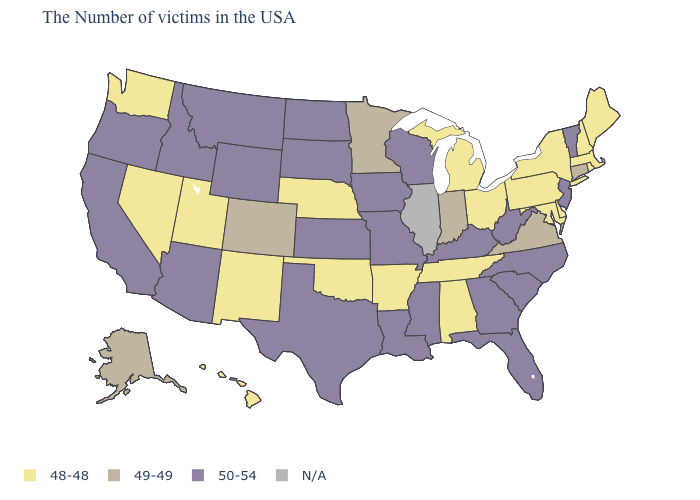Name the states that have a value in the range N/A?
Quick response, please. Illinois. What is the value of Florida?
Write a very short answer. 50-54. What is the value of Massachusetts?
Answer briefly. 48-48. Which states hav the highest value in the MidWest?
Concise answer only. Wisconsin, Missouri, Iowa, Kansas, South Dakota, North Dakota. Does North Carolina have the lowest value in the South?
Keep it brief. No. What is the value of Kansas?
Concise answer only. 50-54. What is the lowest value in the USA?
Give a very brief answer. 48-48. Name the states that have a value in the range 50-54?
Concise answer only. Vermont, New Jersey, North Carolina, South Carolina, West Virginia, Florida, Georgia, Kentucky, Wisconsin, Mississippi, Louisiana, Missouri, Iowa, Kansas, Texas, South Dakota, North Dakota, Wyoming, Montana, Arizona, Idaho, California, Oregon. Name the states that have a value in the range 49-49?
Give a very brief answer. Connecticut, Virginia, Indiana, Minnesota, Colorado, Alaska. What is the highest value in states that border Nebraska?
Quick response, please. 50-54. Among the states that border North Dakota , which have the lowest value?
Concise answer only. Minnesota. Does New Mexico have the lowest value in the USA?
Quick response, please. Yes. What is the lowest value in the MidWest?
Give a very brief answer. 48-48. 